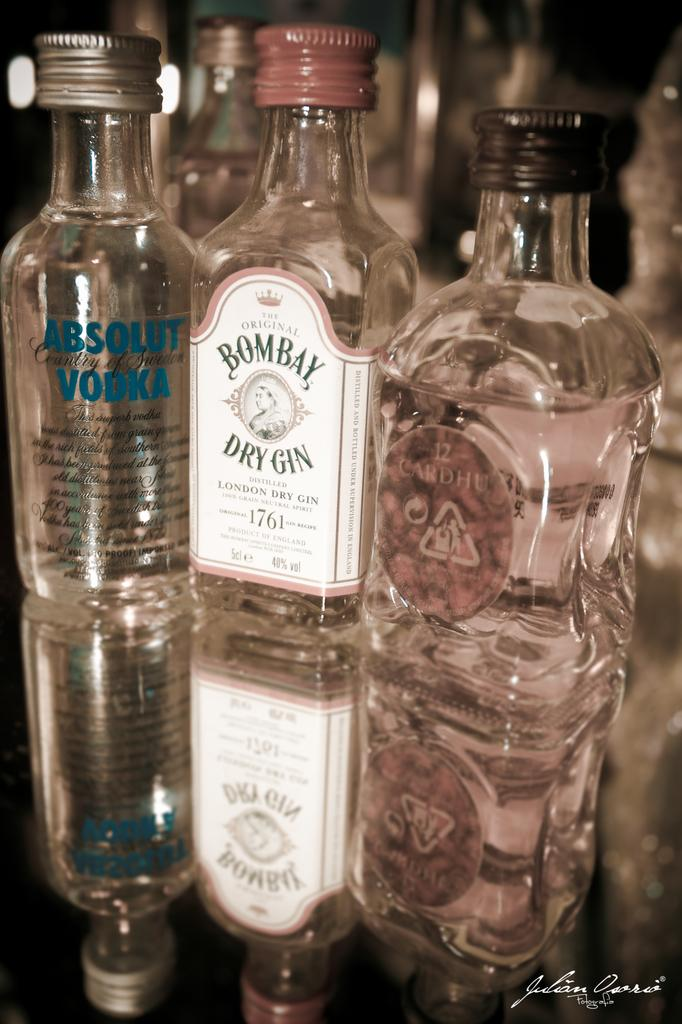How many bottles are on the table in the image? There are three bottles on the table in the image. What are the names of the three bottles? The first bottle is Absolute Vodka, the second bottle is Bombay Gin, and the third bottle is Kardhu. What type of cable is visible in the image? There is no cable present in the image. Can you describe the parent's reaction to the bottles in the image? There is no parent present in the image, so their reaction cannot be described. 